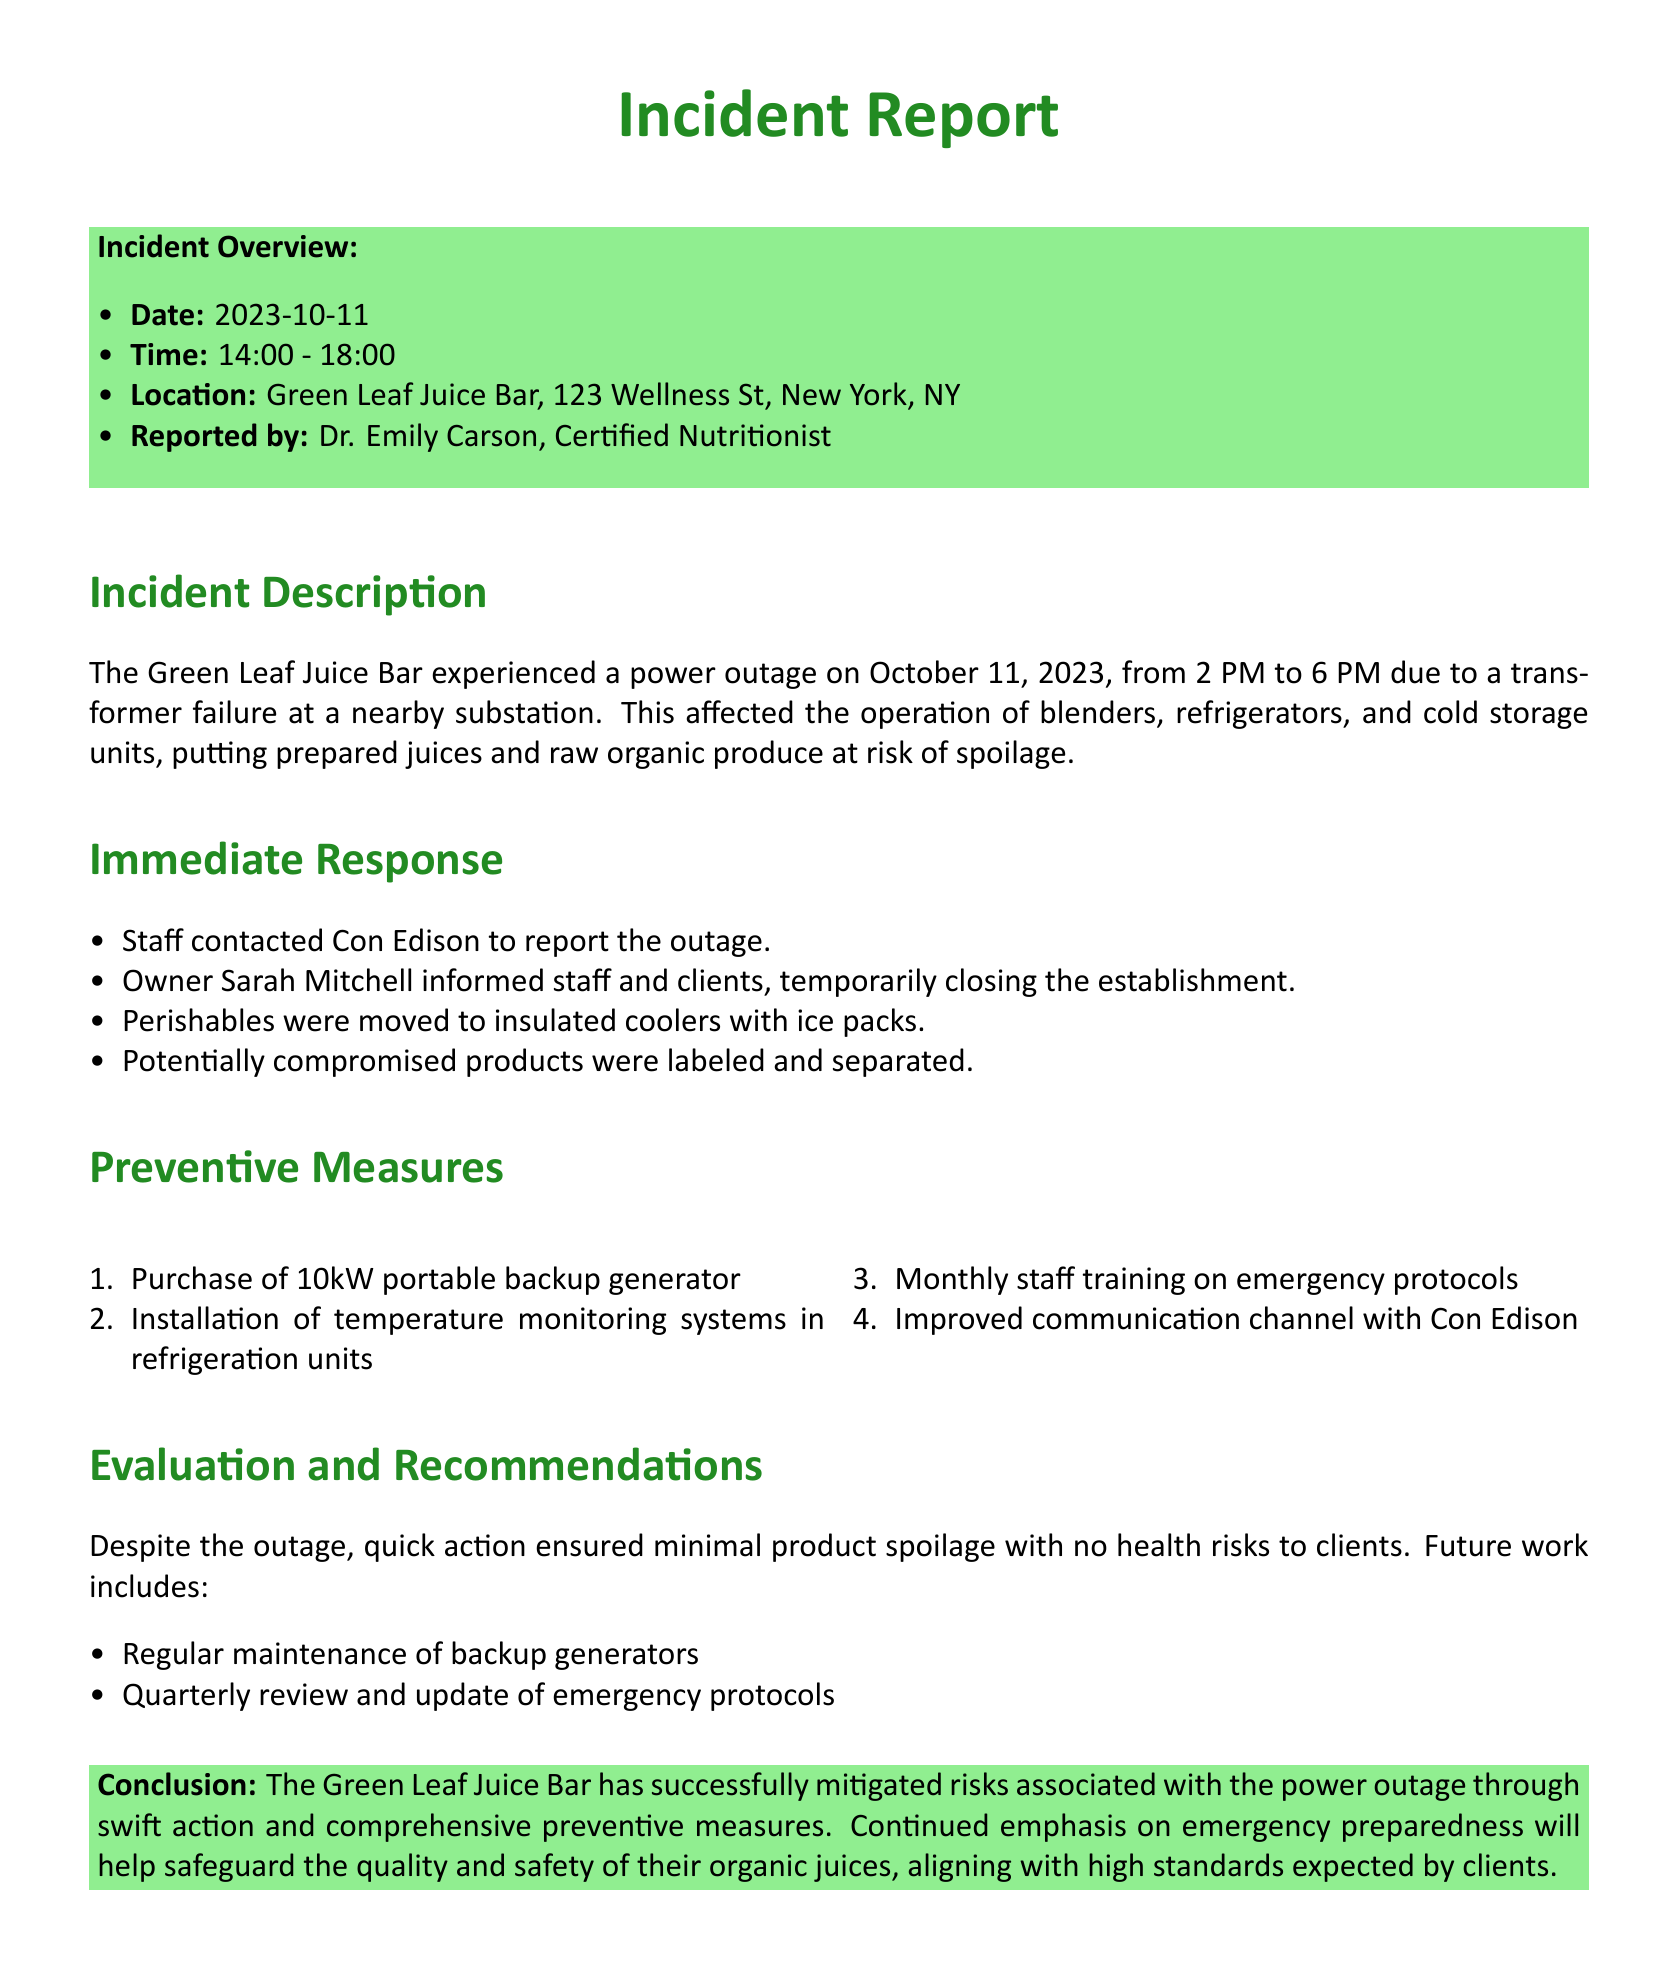What was the date of the incident? The incident occurred on October 11, 2023, as stated in the overview.
Answer: October 11, 2023 What time did the power outage occur? The report specifies the outage lasted from 2 PM to 6 PM.
Answer: 2 PM to 6 PM Who reported the incident? The report indicates that Dr. Emily Carson, Certified Nutritionist, reported the incident.
Answer: Dr. Emily Carson What was used to protect perishables? The immediate response section mentions that perishables were moved to insulated coolers with ice packs.
Answer: Insulated coolers with ice packs How many preventive measures are listed? There are four preventive measures outlined in the document, as listed under the preventive measures section.
Answer: Four What was the reason for the power outage? The incident description states that the power outage was due to a transformer failure at a nearby substation.
Answer: Transformer failure What type of generator was purchased? The preventive measures section lists that a 10kW portable backup generator was purchased.
Answer: 10kW portable backup generator What is one recommendation for future actions? The evaluation section suggests regular maintenance of backup generators as a future action.
Answer: Regular maintenance of backup generators 